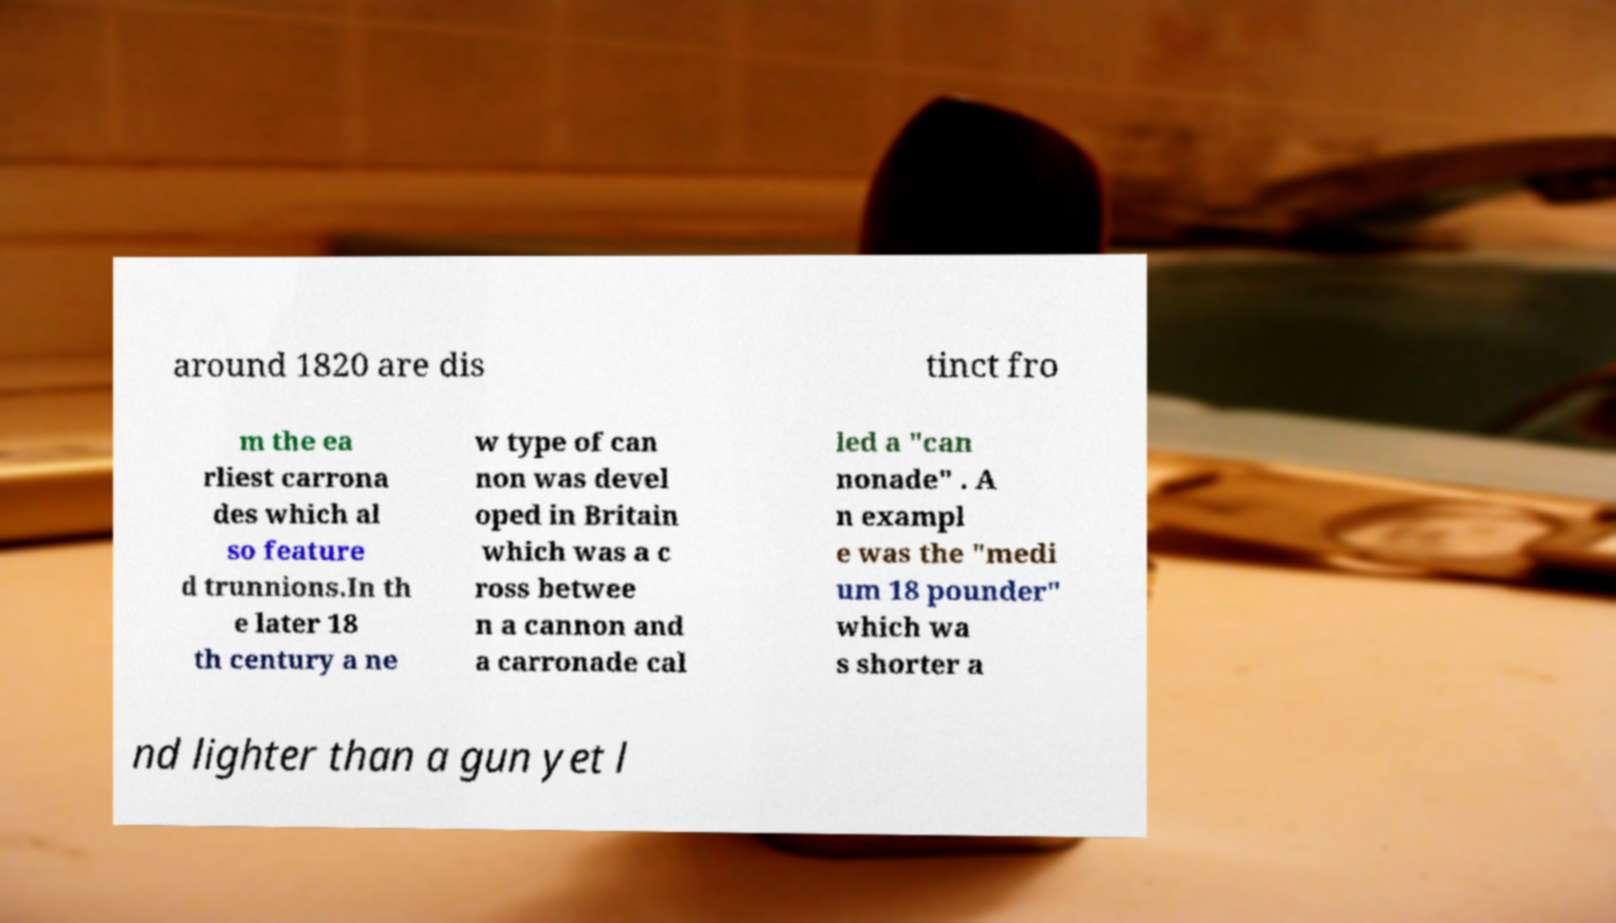I need the written content from this picture converted into text. Can you do that? around 1820 are dis tinct fro m the ea rliest carrona des which al so feature d trunnions.In th e later 18 th century a ne w type of can non was devel oped in Britain which was a c ross betwee n a cannon and a carronade cal led a "can nonade" . A n exampl e was the "medi um 18 pounder" which wa s shorter a nd lighter than a gun yet l 